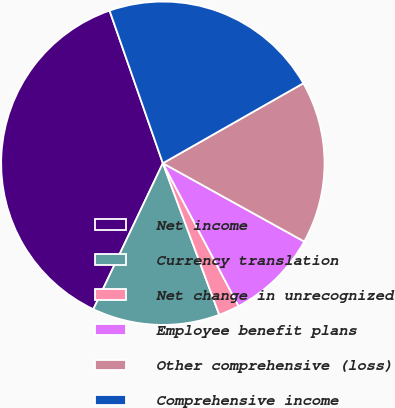Convert chart to OTSL. <chart><loc_0><loc_0><loc_500><loc_500><pie_chart><fcel>Net income<fcel>Currency translation<fcel>Net change in unrecognized<fcel>Employee benefit plans<fcel>Other comprehensive (loss)<fcel>Comprehensive income<nl><fcel>37.59%<fcel>12.74%<fcel>2.09%<fcel>9.19%<fcel>16.29%<fcel>22.11%<nl></chart> 